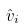<formula> <loc_0><loc_0><loc_500><loc_500>\hat { v } _ { i }</formula> 